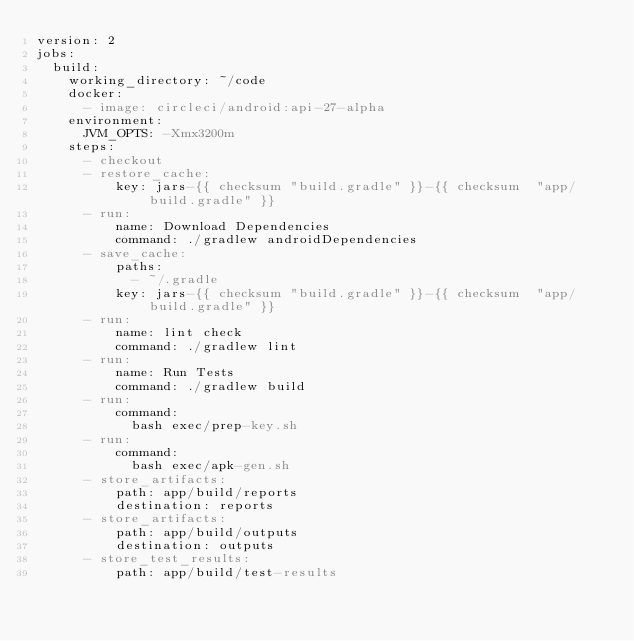Convert code to text. <code><loc_0><loc_0><loc_500><loc_500><_YAML_>version: 2
jobs:
  build:
    working_directory: ~/code
    docker:
      - image: circleci/android:api-27-alpha
    environment:
      JVM_OPTS: -Xmx3200m
    steps:
      - checkout
      - restore_cache:
          key: jars-{{ checksum "build.gradle" }}-{{ checksum  "app/build.gradle" }}
      - run:
          name: Download Dependencies
          command: ./gradlew androidDependencies
      - save_cache:
          paths:
            - ~/.gradle
          key: jars-{{ checksum "build.gradle" }}-{{ checksum  "app/build.gradle" }}
      - run:
          name: lint check
          command: ./gradlew lint
      - run:
          name: Run Tests
          command: ./gradlew build
      - run:
          command:
            bash exec/prep-key.sh
      - run:
          command:
            bash exec/apk-gen.sh
      - store_artifacts:
          path: app/build/reports
          destination: reports
      - store_artifacts:
          path: app/build/outputs
          destination: outputs
      - store_test_results:
          path: app/build/test-results
</code> 